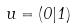Convert formula to latex. <formula><loc_0><loc_0><loc_500><loc_500>u = ( 0 | 1 )</formula> 